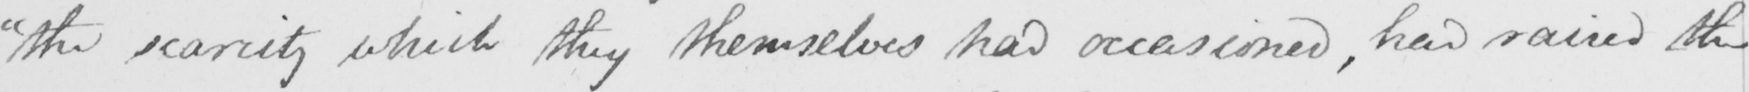What does this handwritten line say? " the scarcity which they themselves had occasioned , had raised the 